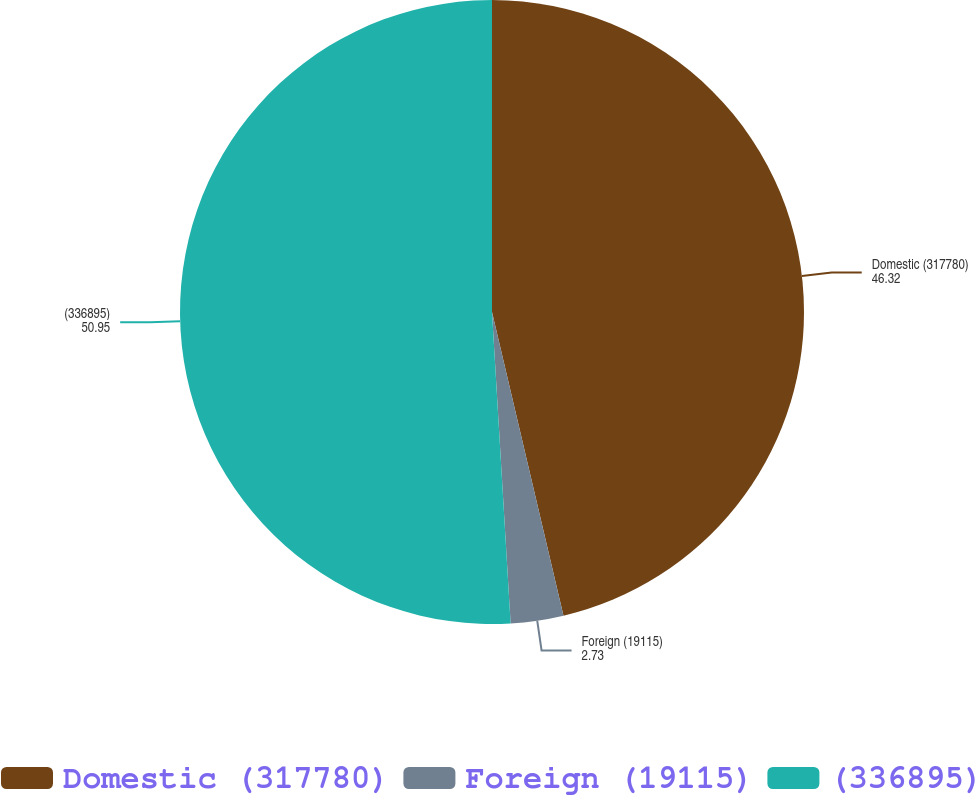Convert chart. <chart><loc_0><loc_0><loc_500><loc_500><pie_chart><fcel>Domestic (317780)<fcel>Foreign (19115)<fcel>(336895)<nl><fcel>46.32%<fcel>2.73%<fcel>50.95%<nl></chart> 